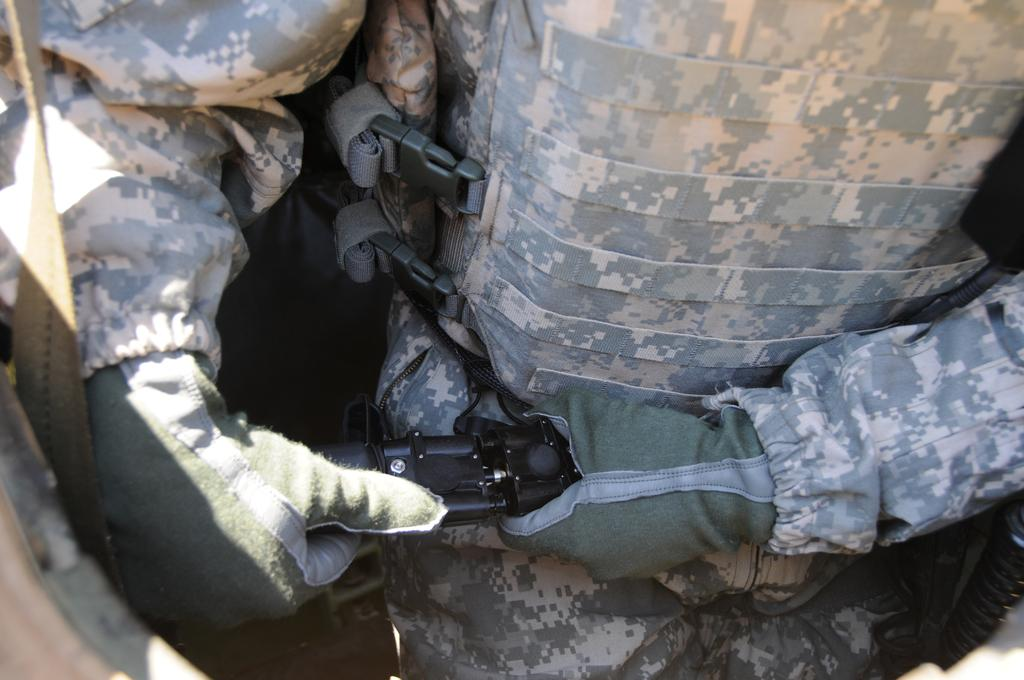Who or what is present in the image? There is a person in the image. What type of clothing is the person wearing? The person is wearing a jacket and gloves. What is the person holding in their hand? The person is holding an object in their hand. What type of rat is visible in the image? There is no rat present in the image. What color are the person's stockings in the image? The person is wearing gloves, not stockings, in the image. 